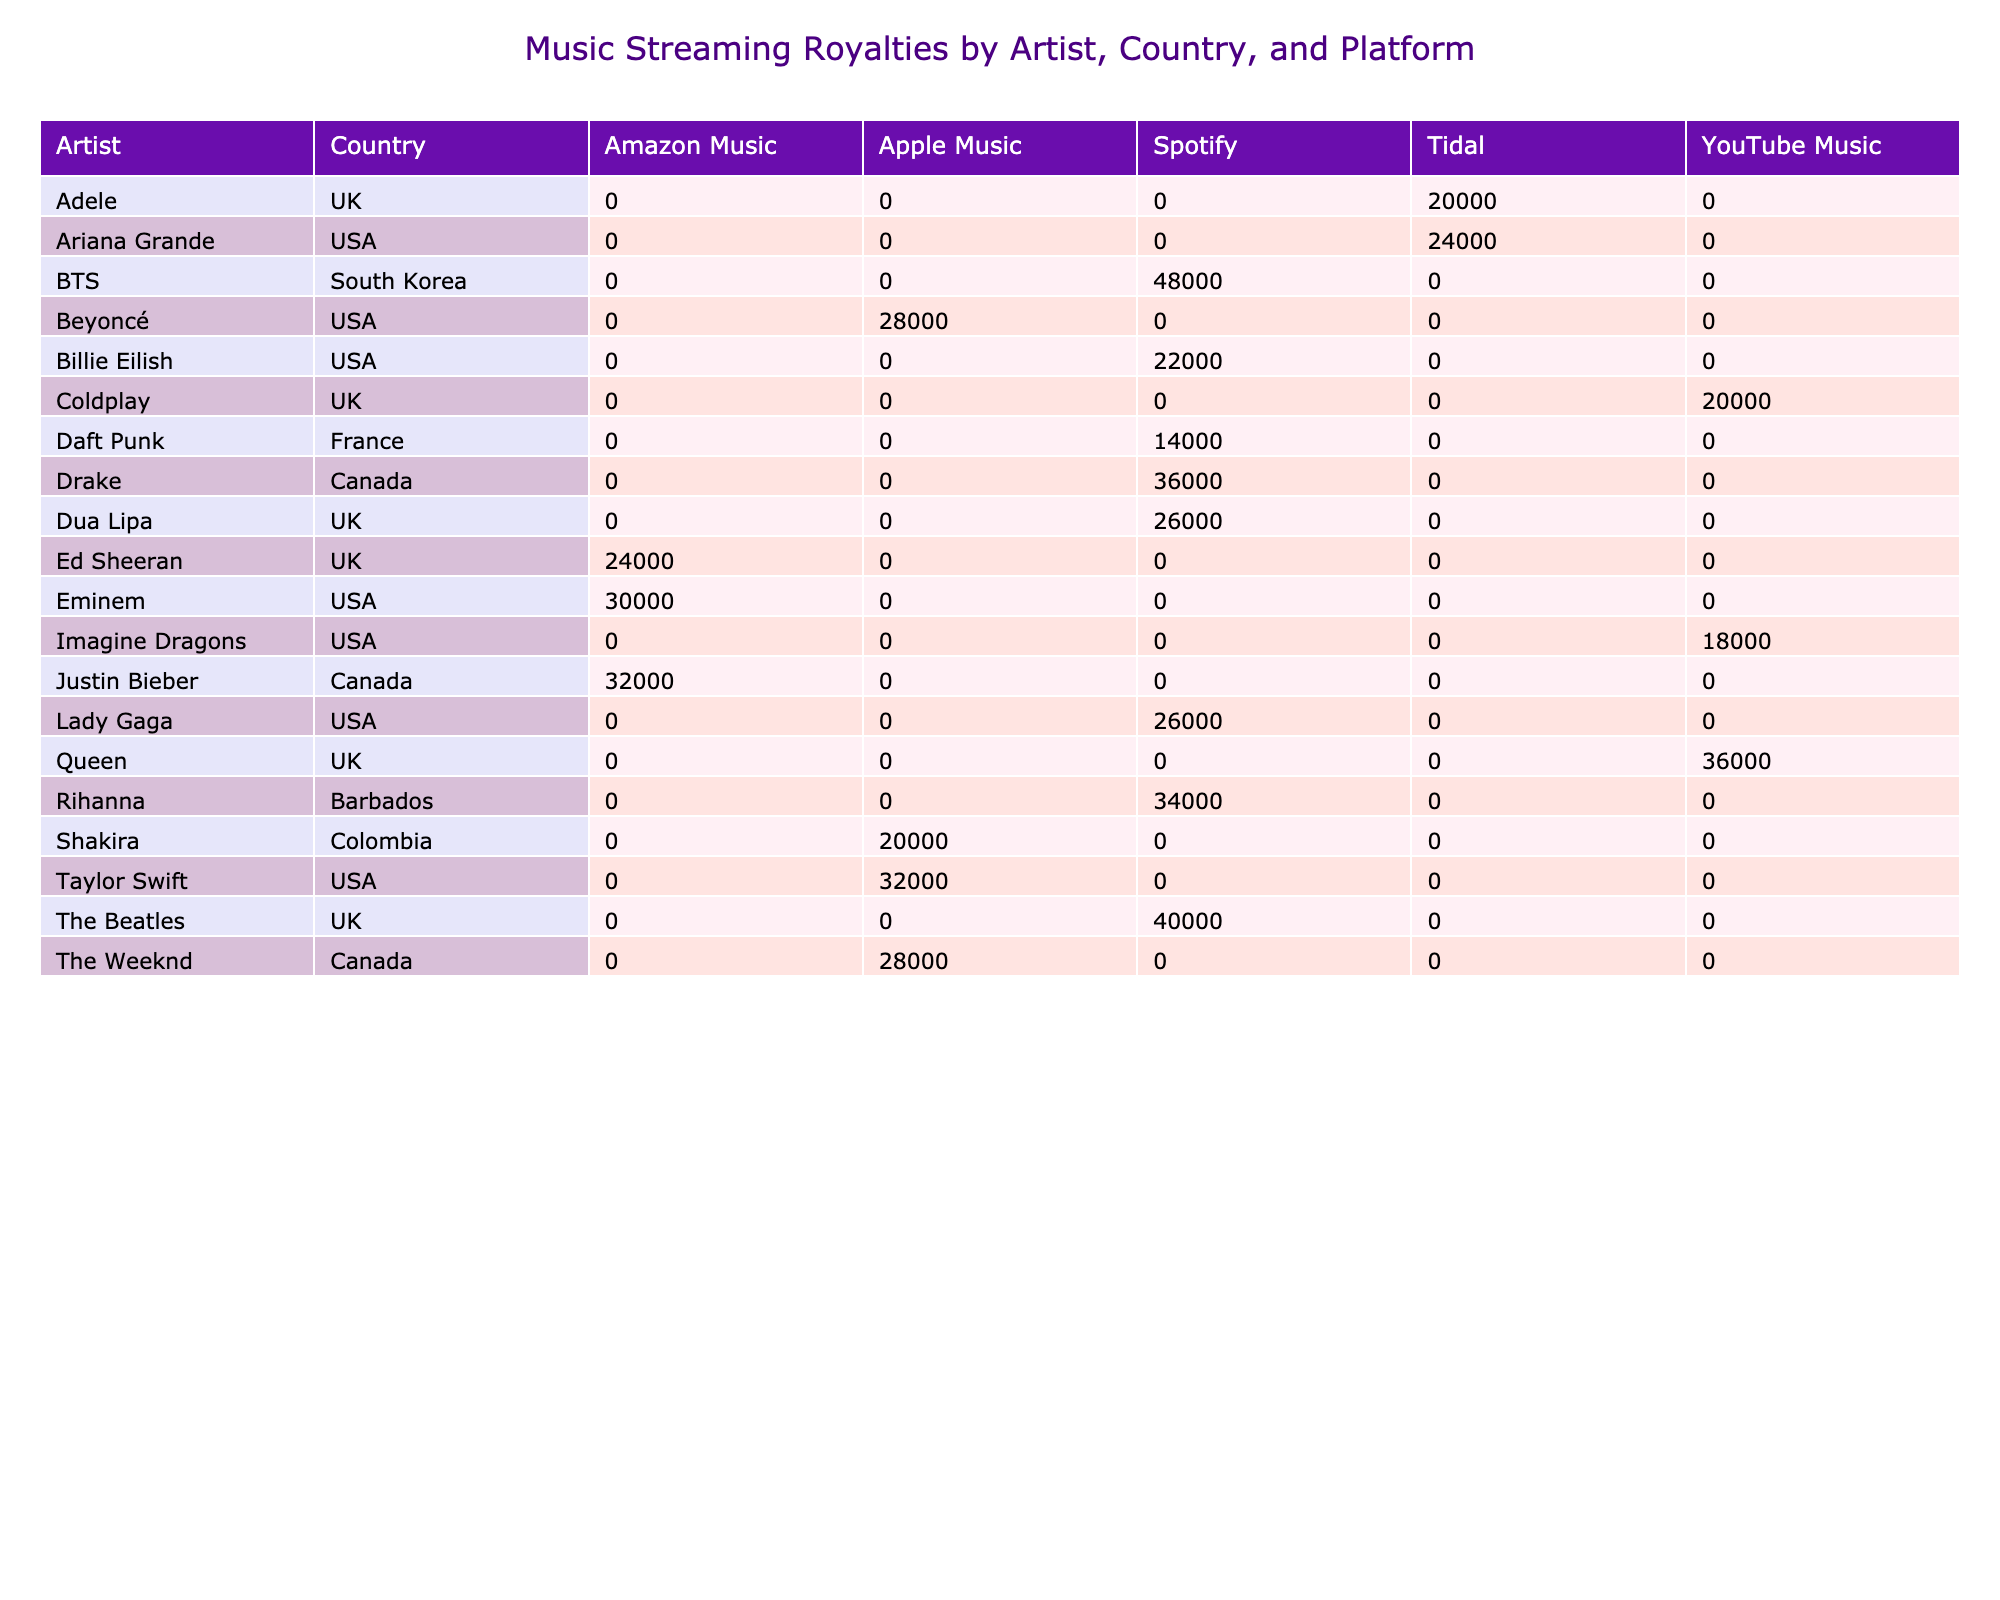What artist from the UK has the highest royalties? By scanning the table for UK artists, I can see that The Beatles have royalties of 40,000, while Ed Sheeran has 24,000, Adele has 20,000, and Dua Lipa has 26,000. Since 40,000 is the highest among these, The Beatles is the answer.
Answer: The Beatles Which artist has the highest total royalties across all platforms? To find the artist with the highest total royalties, I need to look at each artist's royalties. The artist with the highest royalties is BTS with 48,000, which is greater than any other artist’s total.
Answer: BTS Is it true that Drake has more royalties than Rihanna? Referring to the table, Drake has royalties of 36,000 while Rihanna has 34,000. Since 36,000 is greater than 34,000, the statement is true.
Answer: Yes What is the average royalty for artists from the USA? The royalties for USA artists are: Taylor Swift (32,000), Beyoncé (28,000), Eminem (30,000), Ariana Grande (24,000), Billie Eilish (22,000), and Imagine Dragons (18,000). The sum is 32,000 + 28,000 + 30,000 + 24,000 + 22,000 + 18,000 = 154,000. There are 6 artists, so the average is 154,000 / 6 ≈ 25,667.
Answer: 25,667 How many artists from Canada have royalties greater than 30,000? The Canadian artists are Drake (36,000), The Weeknd (28,000), and Justin Bieber (32,000). Among these, only Drake (36,000) and Justin Bieber (32,000) have royalties greater than 30,000. Thus, there are 2 such artists.
Answer: 2 